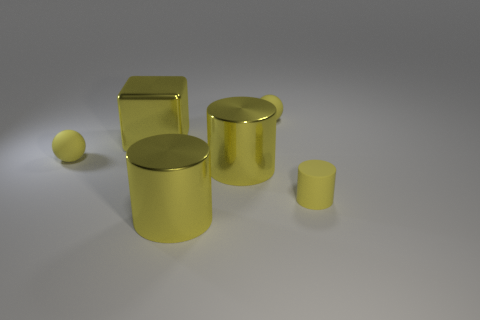Does the small cylinder have the same material as the large cube?
Your answer should be very brief. No. Are there fewer cylinders than big cylinders?
Your response must be concise. No. The small thing that is both in front of the block and behind the tiny yellow rubber cylinder is made of what material?
Offer a terse response. Rubber. What size is the cylinder that is right of the small sphere that is behind the tiny rubber thing that is on the left side of the large cube?
Your answer should be very brief. Small. What number of spheres are both to the left of the large yellow block and right of the large metallic cube?
Provide a succinct answer. 0. What number of yellow things are either large cylinders or matte balls?
Your answer should be very brief. 4. There is a tiny rubber sphere that is behind the big block; is its color the same as the sphere that is in front of the yellow block?
Keep it short and to the point. Yes. The small sphere in front of the small rubber object that is behind the rubber ball in front of the big cube is what color?
Your answer should be very brief. Yellow. There is a cube behind the small yellow cylinder; are there any large shiny blocks to the right of it?
Keep it short and to the point. No. How many cylinders are shiny objects or small cyan matte things?
Provide a short and direct response. 2. 